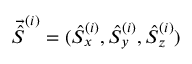<formula> <loc_0><loc_0><loc_500><loc_500>\vec { \hat { S } } ^ { ( i ) } = ( \hat { S } _ { x } ^ { ( i ) } , \hat { S } _ { y } ^ { ( i ) } , \hat { S } _ { z } ^ { ( i ) } )</formula> 